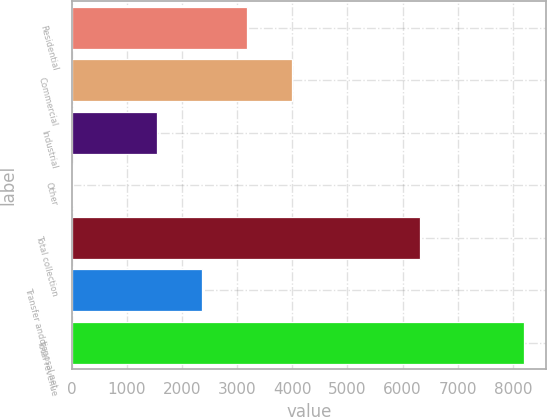<chart> <loc_0><loc_0><loc_500><loc_500><bar_chart><fcel>Residential<fcel>Commercial<fcel>Industrial<fcel>Other<fcel>Total collection<fcel>Transfer anddisposal net<fcel>Total revenue<nl><fcel>3175.84<fcel>3993.06<fcel>1541.4<fcel>26.9<fcel>6308.7<fcel>2358.62<fcel>8199.1<nl></chart> 